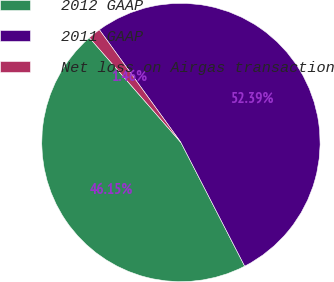Convert chart to OTSL. <chart><loc_0><loc_0><loc_500><loc_500><pie_chart><fcel>2012 GAAP<fcel>2011 GAAP<fcel>Net loss on Airgas transaction<nl><fcel>46.15%<fcel>52.39%<fcel>1.46%<nl></chart> 